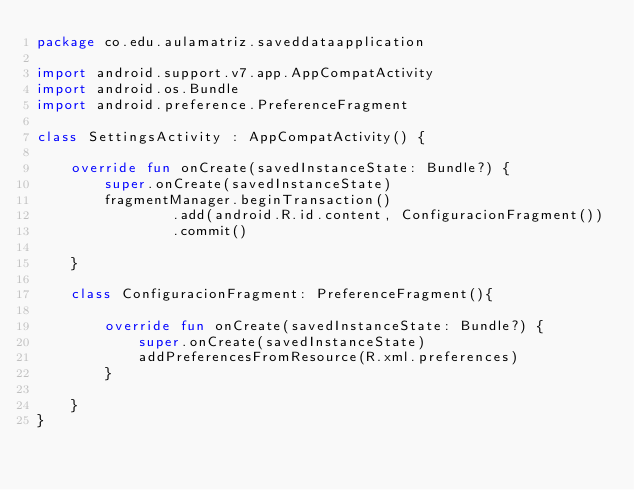Convert code to text. <code><loc_0><loc_0><loc_500><loc_500><_Kotlin_>package co.edu.aulamatriz.saveddataapplication

import android.support.v7.app.AppCompatActivity
import android.os.Bundle
import android.preference.PreferenceFragment

class SettingsActivity : AppCompatActivity() {

    override fun onCreate(savedInstanceState: Bundle?) {
        super.onCreate(savedInstanceState)
        fragmentManager.beginTransaction()
                .add(android.R.id.content, ConfiguracionFragment())
                .commit()

    }

    class ConfiguracionFragment: PreferenceFragment(){

        override fun onCreate(savedInstanceState: Bundle?) {
            super.onCreate(savedInstanceState)
            addPreferencesFromResource(R.xml.preferences)
        }

    }
}
</code> 